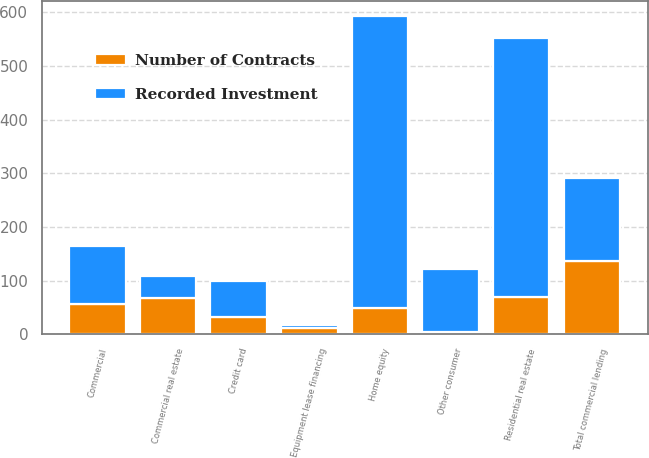Convert chart to OTSL. <chart><loc_0><loc_0><loc_500><loc_500><stacked_bar_chart><ecel><fcel>Commercial<fcel>Commercial real estate<fcel>Equipment lease financing<fcel>Total commercial lending<fcel>Home equity<fcel>Residential real estate<fcel>Credit card<fcel>Other consumer<nl><fcel>Recorded Investment<fcel>108<fcel>41<fcel>6<fcel>155<fcel>542<fcel>482<fcel>68<fcel>118<nl><fcel>Number of Contracts<fcel>57<fcel>68<fcel>12<fcel>137<fcel>50<fcel>70<fcel>32<fcel>4<nl></chart> 